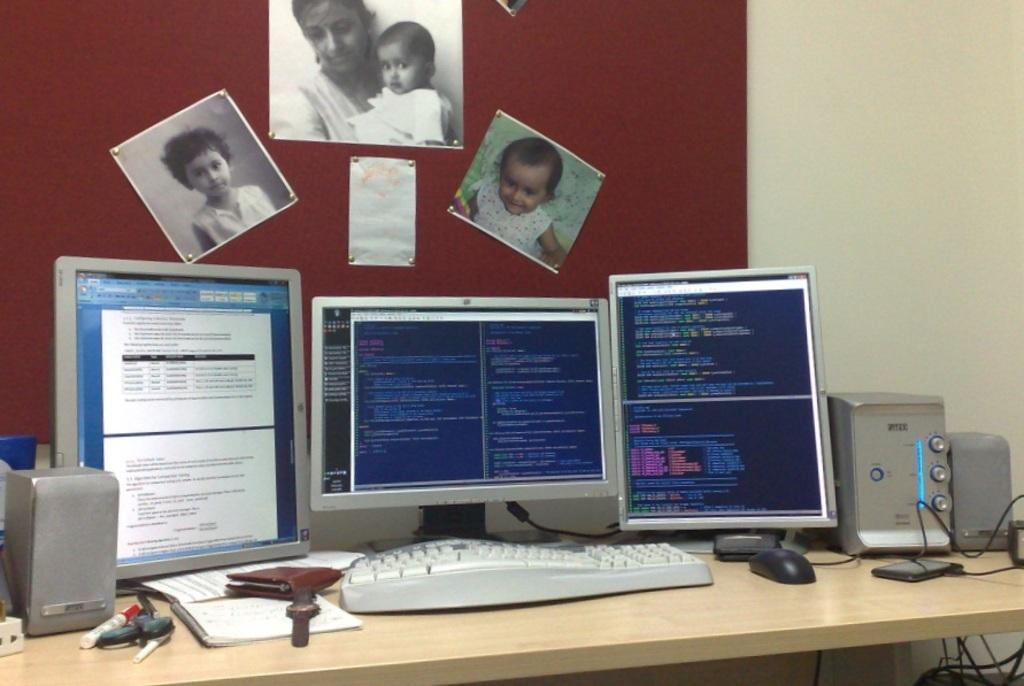What type of furniture is in the image? There is a table in the image. What electronic devices are on the table? There are 3 monitors, a keyboard, speakers, and a mouse on the table. What stationery item is present on the table? A marker is present on the table. What can be seen on the wall in the image? There are 3 photographs and a paper on the wall. How is the hose connected to the computer in the image? There is no hose present in the image; it is not connected to the computer or any other device. 